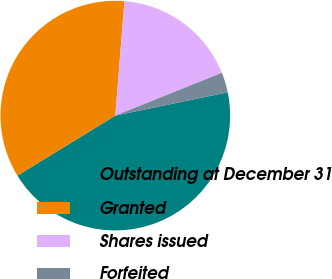<chart> <loc_0><loc_0><loc_500><loc_500><pie_chart><fcel>Outstanding at December 31<fcel>Granted<fcel>Shares issued<fcel>Forfeited<nl><fcel>44.51%<fcel>35.02%<fcel>17.65%<fcel>2.82%<nl></chart> 